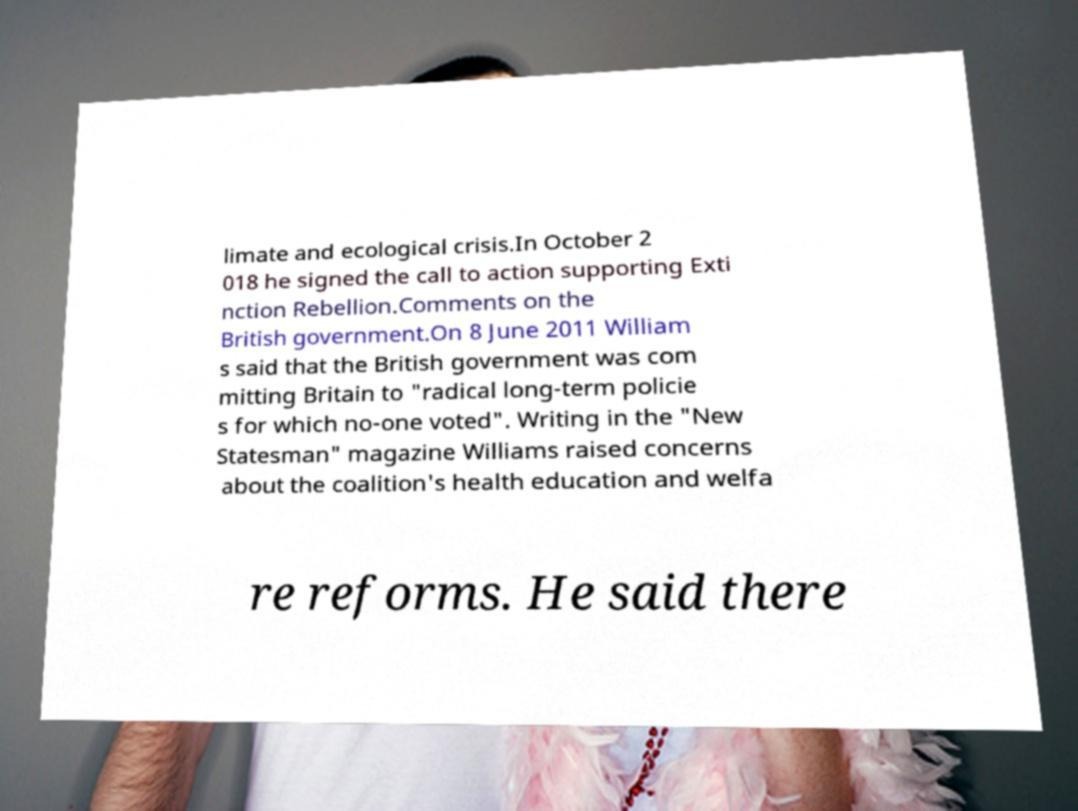What messages or text are displayed in this image? I need them in a readable, typed format. limate and ecological crisis.In October 2 018 he signed the call to action supporting Exti nction Rebellion.Comments on the British government.On 8 June 2011 William s said that the British government was com mitting Britain to "radical long-term policie s for which no-one voted". Writing in the "New Statesman" magazine Williams raised concerns about the coalition's health education and welfa re reforms. He said there 